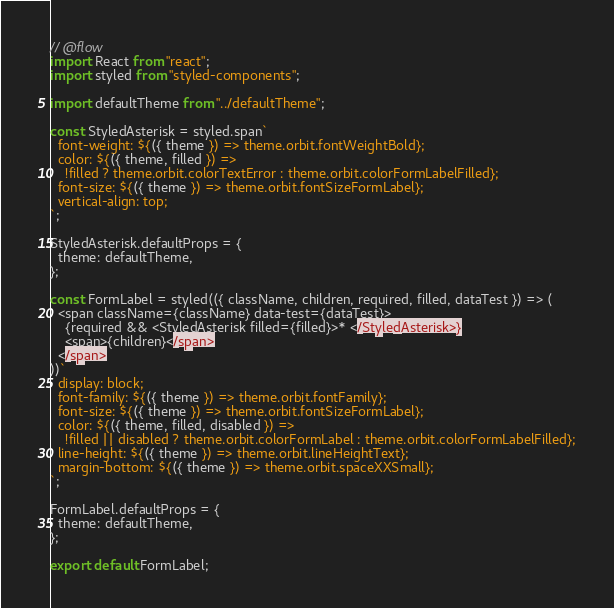Convert code to text. <code><loc_0><loc_0><loc_500><loc_500><_JavaScript_>// @flow
import React from "react";
import styled from "styled-components";

import defaultTheme from "../defaultTheme";

const StyledAsterisk = styled.span`
  font-weight: ${({ theme }) => theme.orbit.fontWeightBold};
  color: ${({ theme, filled }) =>
    !filled ? theme.orbit.colorTextError : theme.orbit.colorFormLabelFilled};
  font-size: ${({ theme }) => theme.orbit.fontSizeFormLabel};
  vertical-align: top;
`;

StyledAsterisk.defaultProps = {
  theme: defaultTheme,
};

const FormLabel = styled(({ className, children, required, filled, dataTest }) => (
  <span className={className} data-test={dataTest}>
    {required && <StyledAsterisk filled={filled}>* </StyledAsterisk>}
    <span>{children}</span>
  </span>
))`
  display: block;
  font-family: ${({ theme }) => theme.orbit.fontFamily};
  font-size: ${({ theme }) => theme.orbit.fontSizeFormLabel};
  color: ${({ theme, filled, disabled }) =>
    !filled || disabled ? theme.orbit.colorFormLabel : theme.orbit.colorFormLabelFilled};
  line-height: ${({ theme }) => theme.orbit.lineHeightText};
  margin-bottom: ${({ theme }) => theme.orbit.spaceXXSmall};
`;

FormLabel.defaultProps = {
  theme: defaultTheme,
};

export default FormLabel;
</code> 